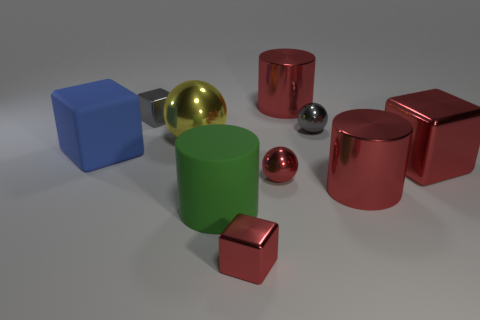There is another ball that is the same size as the red shiny sphere; what color is it?
Your response must be concise. Gray. Does the yellow thing have the same size as the gray object on the right side of the small gray shiny block?
Your answer should be compact. No. What number of objects have the same color as the big shiny block?
Give a very brief answer. 4. How many objects are either big cylinders or red objects left of the small gray sphere?
Your response must be concise. 5. There is a red metallic cylinder in front of the yellow sphere; is it the same size as the gray object that is right of the gray cube?
Offer a very short reply. No. Are there any big green things that have the same material as the blue object?
Your answer should be compact. Yes. The large green thing has what shape?
Keep it short and to the point. Cylinder. There is a large red shiny object that is behind the big ball on the left side of the red sphere; what is its shape?
Your answer should be very brief. Cylinder. What number of other objects are the same shape as the blue matte thing?
Your answer should be very brief. 3. What size is the rubber object that is on the right side of the matte thing that is on the left side of the large green cylinder?
Ensure brevity in your answer.  Large. 